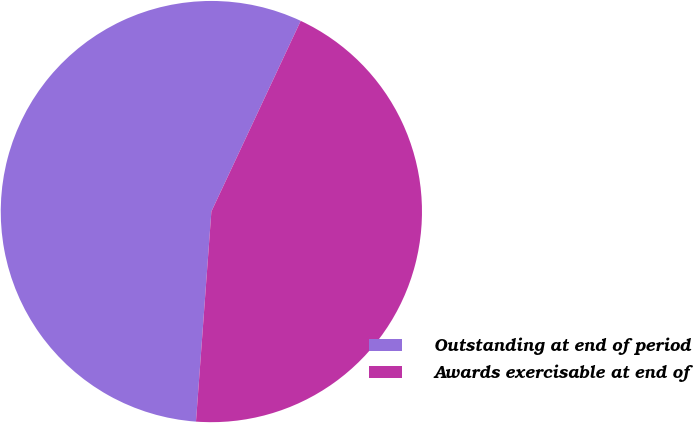<chart> <loc_0><loc_0><loc_500><loc_500><pie_chart><fcel>Outstanding at end of period<fcel>Awards exercisable at end of<nl><fcel>55.81%<fcel>44.19%<nl></chart> 